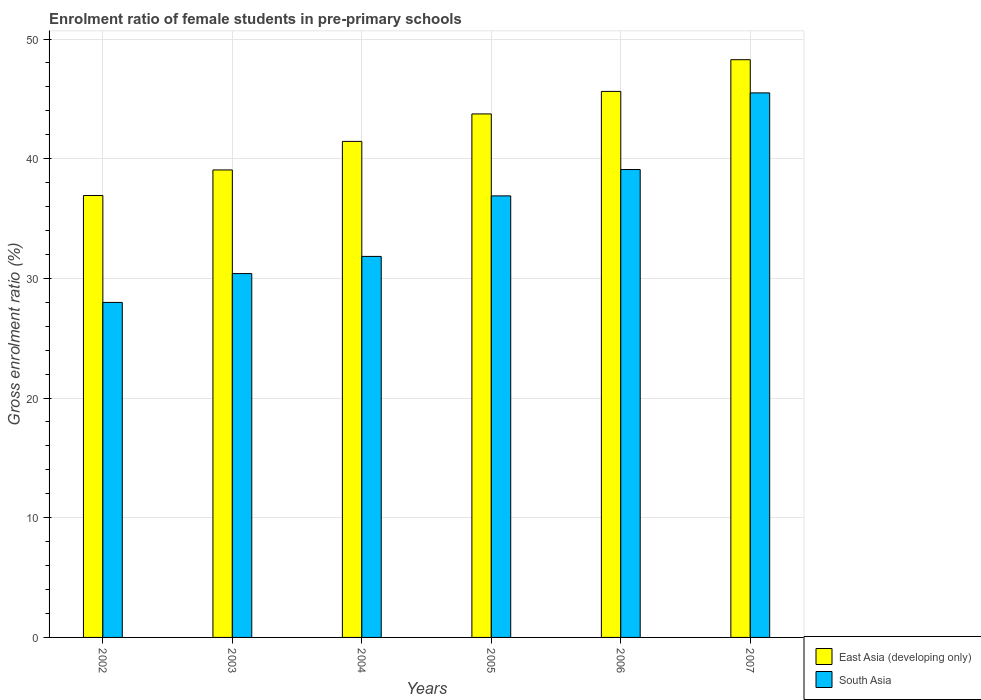How many different coloured bars are there?
Offer a terse response. 2. Are the number of bars per tick equal to the number of legend labels?
Offer a terse response. Yes. Are the number of bars on each tick of the X-axis equal?
Your answer should be very brief. Yes. In how many cases, is the number of bars for a given year not equal to the number of legend labels?
Ensure brevity in your answer.  0. What is the enrolment ratio of female students in pre-primary schools in East Asia (developing only) in 2005?
Give a very brief answer. 43.74. Across all years, what is the maximum enrolment ratio of female students in pre-primary schools in East Asia (developing only)?
Make the answer very short. 48.27. Across all years, what is the minimum enrolment ratio of female students in pre-primary schools in East Asia (developing only)?
Provide a succinct answer. 36.92. In which year was the enrolment ratio of female students in pre-primary schools in East Asia (developing only) maximum?
Provide a short and direct response. 2007. What is the total enrolment ratio of female students in pre-primary schools in East Asia (developing only) in the graph?
Offer a very short reply. 255.06. What is the difference between the enrolment ratio of female students in pre-primary schools in South Asia in 2002 and that in 2003?
Keep it short and to the point. -2.41. What is the difference between the enrolment ratio of female students in pre-primary schools in South Asia in 2007 and the enrolment ratio of female students in pre-primary schools in East Asia (developing only) in 2003?
Keep it short and to the point. 6.44. What is the average enrolment ratio of female students in pre-primary schools in East Asia (developing only) per year?
Offer a very short reply. 42.51. In the year 2006, what is the difference between the enrolment ratio of female students in pre-primary schools in East Asia (developing only) and enrolment ratio of female students in pre-primary schools in South Asia?
Ensure brevity in your answer.  6.53. What is the ratio of the enrolment ratio of female students in pre-primary schools in South Asia in 2003 to that in 2004?
Offer a terse response. 0.95. Is the enrolment ratio of female students in pre-primary schools in East Asia (developing only) in 2005 less than that in 2007?
Ensure brevity in your answer.  Yes. What is the difference between the highest and the second highest enrolment ratio of female students in pre-primary schools in South Asia?
Your answer should be very brief. 6.4. What is the difference between the highest and the lowest enrolment ratio of female students in pre-primary schools in East Asia (developing only)?
Provide a succinct answer. 11.35. In how many years, is the enrolment ratio of female students in pre-primary schools in South Asia greater than the average enrolment ratio of female students in pre-primary schools in South Asia taken over all years?
Your answer should be compact. 3. What does the 2nd bar from the left in 2007 represents?
Give a very brief answer. South Asia. What is the difference between two consecutive major ticks on the Y-axis?
Provide a short and direct response. 10. Are the values on the major ticks of Y-axis written in scientific E-notation?
Your answer should be compact. No. Does the graph contain any zero values?
Provide a short and direct response. No. Where does the legend appear in the graph?
Your response must be concise. Bottom right. What is the title of the graph?
Provide a short and direct response. Enrolment ratio of female students in pre-primary schools. Does "Jamaica" appear as one of the legend labels in the graph?
Provide a short and direct response. No. What is the Gross enrolment ratio (%) in East Asia (developing only) in 2002?
Offer a very short reply. 36.92. What is the Gross enrolment ratio (%) in South Asia in 2002?
Keep it short and to the point. 27.99. What is the Gross enrolment ratio (%) of East Asia (developing only) in 2003?
Make the answer very short. 39.06. What is the Gross enrolment ratio (%) in South Asia in 2003?
Ensure brevity in your answer.  30.4. What is the Gross enrolment ratio (%) of East Asia (developing only) in 2004?
Your response must be concise. 41.45. What is the Gross enrolment ratio (%) in South Asia in 2004?
Give a very brief answer. 31.84. What is the Gross enrolment ratio (%) in East Asia (developing only) in 2005?
Give a very brief answer. 43.74. What is the Gross enrolment ratio (%) of South Asia in 2005?
Give a very brief answer. 36.89. What is the Gross enrolment ratio (%) of East Asia (developing only) in 2006?
Your answer should be very brief. 45.62. What is the Gross enrolment ratio (%) of South Asia in 2006?
Make the answer very short. 39.09. What is the Gross enrolment ratio (%) of East Asia (developing only) in 2007?
Give a very brief answer. 48.27. What is the Gross enrolment ratio (%) in South Asia in 2007?
Your answer should be very brief. 45.5. Across all years, what is the maximum Gross enrolment ratio (%) in East Asia (developing only)?
Your answer should be compact. 48.27. Across all years, what is the maximum Gross enrolment ratio (%) in South Asia?
Keep it short and to the point. 45.5. Across all years, what is the minimum Gross enrolment ratio (%) in East Asia (developing only)?
Provide a succinct answer. 36.92. Across all years, what is the minimum Gross enrolment ratio (%) in South Asia?
Ensure brevity in your answer.  27.99. What is the total Gross enrolment ratio (%) of East Asia (developing only) in the graph?
Provide a succinct answer. 255.06. What is the total Gross enrolment ratio (%) of South Asia in the graph?
Your response must be concise. 211.71. What is the difference between the Gross enrolment ratio (%) in East Asia (developing only) in 2002 and that in 2003?
Offer a very short reply. -2.14. What is the difference between the Gross enrolment ratio (%) of South Asia in 2002 and that in 2003?
Make the answer very short. -2.41. What is the difference between the Gross enrolment ratio (%) in East Asia (developing only) in 2002 and that in 2004?
Your answer should be very brief. -4.52. What is the difference between the Gross enrolment ratio (%) in South Asia in 2002 and that in 2004?
Your answer should be very brief. -3.84. What is the difference between the Gross enrolment ratio (%) of East Asia (developing only) in 2002 and that in 2005?
Offer a terse response. -6.82. What is the difference between the Gross enrolment ratio (%) in South Asia in 2002 and that in 2005?
Your answer should be very brief. -8.9. What is the difference between the Gross enrolment ratio (%) in East Asia (developing only) in 2002 and that in 2006?
Give a very brief answer. -8.7. What is the difference between the Gross enrolment ratio (%) of South Asia in 2002 and that in 2006?
Your answer should be compact. -11.1. What is the difference between the Gross enrolment ratio (%) in East Asia (developing only) in 2002 and that in 2007?
Offer a terse response. -11.35. What is the difference between the Gross enrolment ratio (%) of South Asia in 2002 and that in 2007?
Your answer should be very brief. -17.51. What is the difference between the Gross enrolment ratio (%) of East Asia (developing only) in 2003 and that in 2004?
Offer a very short reply. -2.39. What is the difference between the Gross enrolment ratio (%) in South Asia in 2003 and that in 2004?
Provide a succinct answer. -1.44. What is the difference between the Gross enrolment ratio (%) in East Asia (developing only) in 2003 and that in 2005?
Offer a terse response. -4.68. What is the difference between the Gross enrolment ratio (%) in South Asia in 2003 and that in 2005?
Provide a succinct answer. -6.49. What is the difference between the Gross enrolment ratio (%) of East Asia (developing only) in 2003 and that in 2006?
Give a very brief answer. -6.56. What is the difference between the Gross enrolment ratio (%) in South Asia in 2003 and that in 2006?
Ensure brevity in your answer.  -8.69. What is the difference between the Gross enrolment ratio (%) in East Asia (developing only) in 2003 and that in 2007?
Your answer should be very brief. -9.21. What is the difference between the Gross enrolment ratio (%) of South Asia in 2003 and that in 2007?
Give a very brief answer. -15.1. What is the difference between the Gross enrolment ratio (%) of East Asia (developing only) in 2004 and that in 2005?
Your answer should be very brief. -2.29. What is the difference between the Gross enrolment ratio (%) in South Asia in 2004 and that in 2005?
Your response must be concise. -5.06. What is the difference between the Gross enrolment ratio (%) of East Asia (developing only) in 2004 and that in 2006?
Give a very brief answer. -4.18. What is the difference between the Gross enrolment ratio (%) of South Asia in 2004 and that in 2006?
Offer a terse response. -7.26. What is the difference between the Gross enrolment ratio (%) in East Asia (developing only) in 2004 and that in 2007?
Make the answer very short. -6.82. What is the difference between the Gross enrolment ratio (%) in South Asia in 2004 and that in 2007?
Keep it short and to the point. -13.66. What is the difference between the Gross enrolment ratio (%) in East Asia (developing only) in 2005 and that in 2006?
Keep it short and to the point. -1.88. What is the difference between the Gross enrolment ratio (%) in South Asia in 2005 and that in 2006?
Provide a succinct answer. -2.2. What is the difference between the Gross enrolment ratio (%) of East Asia (developing only) in 2005 and that in 2007?
Offer a very short reply. -4.53. What is the difference between the Gross enrolment ratio (%) in South Asia in 2005 and that in 2007?
Offer a terse response. -8.61. What is the difference between the Gross enrolment ratio (%) in East Asia (developing only) in 2006 and that in 2007?
Your answer should be compact. -2.65. What is the difference between the Gross enrolment ratio (%) in South Asia in 2006 and that in 2007?
Keep it short and to the point. -6.4. What is the difference between the Gross enrolment ratio (%) of East Asia (developing only) in 2002 and the Gross enrolment ratio (%) of South Asia in 2003?
Ensure brevity in your answer.  6.52. What is the difference between the Gross enrolment ratio (%) of East Asia (developing only) in 2002 and the Gross enrolment ratio (%) of South Asia in 2004?
Offer a very short reply. 5.09. What is the difference between the Gross enrolment ratio (%) in East Asia (developing only) in 2002 and the Gross enrolment ratio (%) in South Asia in 2005?
Offer a terse response. 0.03. What is the difference between the Gross enrolment ratio (%) in East Asia (developing only) in 2002 and the Gross enrolment ratio (%) in South Asia in 2006?
Provide a succinct answer. -2.17. What is the difference between the Gross enrolment ratio (%) in East Asia (developing only) in 2002 and the Gross enrolment ratio (%) in South Asia in 2007?
Your response must be concise. -8.57. What is the difference between the Gross enrolment ratio (%) of East Asia (developing only) in 2003 and the Gross enrolment ratio (%) of South Asia in 2004?
Your response must be concise. 7.22. What is the difference between the Gross enrolment ratio (%) of East Asia (developing only) in 2003 and the Gross enrolment ratio (%) of South Asia in 2005?
Make the answer very short. 2.17. What is the difference between the Gross enrolment ratio (%) in East Asia (developing only) in 2003 and the Gross enrolment ratio (%) in South Asia in 2006?
Your answer should be compact. -0.03. What is the difference between the Gross enrolment ratio (%) of East Asia (developing only) in 2003 and the Gross enrolment ratio (%) of South Asia in 2007?
Keep it short and to the point. -6.44. What is the difference between the Gross enrolment ratio (%) in East Asia (developing only) in 2004 and the Gross enrolment ratio (%) in South Asia in 2005?
Provide a succinct answer. 4.55. What is the difference between the Gross enrolment ratio (%) in East Asia (developing only) in 2004 and the Gross enrolment ratio (%) in South Asia in 2006?
Your answer should be compact. 2.35. What is the difference between the Gross enrolment ratio (%) of East Asia (developing only) in 2004 and the Gross enrolment ratio (%) of South Asia in 2007?
Ensure brevity in your answer.  -4.05. What is the difference between the Gross enrolment ratio (%) in East Asia (developing only) in 2005 and the Gross enrolment ratio (%) in South Asia in 2006?
Ensure brevity in your answer.  4.65. What is the difference between the Gross enrolment ratio (%) in East Asia (developing only) in 2005 and the Gross enrolment ratio (%) in South Asia in 2007?
Give a very brief answer. -1.76. What is the difference between the Gross enrolment ratio (%) of East Asia (developing only) in 2006 and the Gross enrolment ratio (%) of South Asia in 2007?
Provide a succinct answer. 0.12. What is the average Gross enrolment ratio (%) of East Asia (developing only) per year?
Provide a succinct answer. 42.51. What is the average Gross enrolment ratio (%) of South Asia per year?
Offer a very short reply. 35.28. In the year 2002, what is the difference between the Gross enrolment ratio (%) of East Asia (developing only) and Gross enrolment ratio (%) of South Asia?
Your response must be concise. 8.93. In the year 2003, what is the difference between the Gross enrolment ratio (%) of East Asia (developing only) and Gross enrolment ratio (%) of South Asia?
Your answer should be very brief. 8.66. In the year 2004, what is the difference between the Gross enrolment ratio (%) of East Asia (developing only) and Gross enrolment ratio (%) of South Asia?
Offer a terse response. 9.61. In the year 2005, what is the difference between the Gross enrolment ratio (%) in East Asia (developing only) and Gross enrolment ratio (%) in South Asia?
Provide a succinct answer. 6.85. In the year 2006, what is the difference between the Gross enrolment ratio (%) of East Asia (developing only) and Gross enrolment ratio (%) of South Asia?
Make the answer very short. 6.53. In the year 2007, what is the difference between the Gross enrolment ratio (%) in East Asia (developing only) and Gross enrolment ratio (%) in South Asia?
Provide a succinct answer. 2.77. What is the ratio of the Gross enrolment ratio (%) of East Asia (developing only) in 2002 to that in 2003?
Offer a terse response. 0.95. What is the ratio of the Gross enrolment ratio (%) of South Asia in 2002 to that in 2003?
Your answer should be very brief. 0.92. What is the ratio of the Gross enrolment ratio (%) in East Asia (developing only) in 2002 to that in 2004?
Provide a succinct answer. 0.89. What is the ratio of the Gross enrolment ratio (%) in South Asia in 2002 to that in 2004?
Give a very brief answer. 0.88. What is the ratio of the Gross enrolment ratio (%) in East Asia (developing only) in 2002 to that in 2005?
Ensure brevity in your answer.  0.84. What is the ratio of the Gross enrolment ratio (%) in South Asia in 2002 to that in 2005?
Ensure brevity in your answer.  0.76. What is the ratio of the Gross enrolment ratio (%) of East Asia (developing only) in 2002 to that in 2006?
Provide a succinct answer. 0.81. What is the ratio of the Gross enrolment ratio (%) of South Asia in 2002 to that in 2006?
Your response must be concise. 0.72. What is the ratio of the Gross enrolment ratio (%) of East Asia (developing only) in 2002 to that in 2007?
Offer a terse response. 0.76. What is the ratio of the Gross enrolment ratio (%) of South Asia in 2002 to that in 2007?
Your answer should be very brief. 0.62. What is the ratio of the Gross enrolment ratio (%) in East Asia (developing only) in 2003 to that in 2004?
Make the answer very short. 0.94. What is the ratio of the Gross enrolment ratio (%) of South Asia in 2003 to that in 2004?
Give a very brief answer. 0.95. What is the ratio of the Gross enrolment ratio (%) of East Asia (developing only) in 2003 to that in 2005?
Provide a succinct answer. 0.89. What is the ratio of the Gross enrolment ratio (%) in South Asia in 2003 to that in 2005?
Your response must be concise. 0.82. What is the ratio of the Gross enrolment ratio (%) of East Asia (developing only) in 2003 to that in 2006?
Ensure brevity in your answer.  0.86. What is the ratio of the Gross enrolment ratio (%) of South Asia in 2003 to that in 2006?
Ensure brevity in your answer.  0.78. What is the ratio of the Gross enrolment ratio (%) of East Asia (developing only) in 2003 to that in 2007?
Your answer should be very brief. 0.81. What is the ratio of the Gross enrolment ratio (%) in South Asia in 2003 to that in 2007?
Provide a succinct answer. 0.67. What is the ratio of the Gross enrolment ratio (%) of East Asia (developing only) in 2004 to that in 2005?
Give a very brief answer. 0.95. What is the ratio of the Gross enrolment ratio (%) in South Asia in 2004 to that in 2005?
Offer a very short reply. 0.86. What is the ratio of the Gross enrolment ratio (%) of East Asia (developing only) in 2004 to that in 2006?
Give a very brief answer. 0.91. What is the ratio of the Gross enrolment ratio (%) of South Asia in 2004 to that in 2006?
Provide a succinct answer. 0.81. What is the ratio of the Gross enrolment ratio (%) of East Asia (developing only) in 2004 to that in 2007?
Offer a terse response. 0.86. What is the ratio of the Gross enrolment ratio (%) of South Asia in 2004 to that in 2007?
Offer a terse response. 0.7. What is the ratio of the Gross enrolment ratio (%) of East Asia (developing only) in 2005 to that in 2006?
Your response must be concise. 0.96. What is the ratio of the Gross enrolment ratio (%) of South Asia in 2005 to that in 2006?
Offer a very short reply. 0.94. What is the ratio of the Gross enrolment ratio (%) in East Asia (developing only) in 2005 to that in 2007?
Give a very brief answer. 0.91. What is the ratio of the Gross enrolment ratio (%) in South Asia in 2005 to that in 2007?
Keep it short and to the point. 0.81. What is the ratio of the Gross enrolment ratio (%) in East Asia (developing only) in 2006 to that in 2007?
Provide a short and direct response. 0.95. What is the ratio of the Gross enrolment ratio (%) in South Asia in 2006 to that in 2007?
Provide a succinct answer. 0.86. What is the difference between the highest and the second highest Gross enrolment ratio (%) in East Asia (developing only)?
Your response must be concise. 2.65. What is the difference between the highest and the second highest Gross enrolment ratio (%) of South Asia?
Offer a very short reply. 6.4. What is the difference between the highest and the lowest Gross enrolment ratio (%) in East Asia (developing only)?
Ensure brevity in your answer.  11.35. What is the difference between the highest and the lowest Gross enrolment ratio (%) of South Asia?
Offer a very short reply. 17.51. 